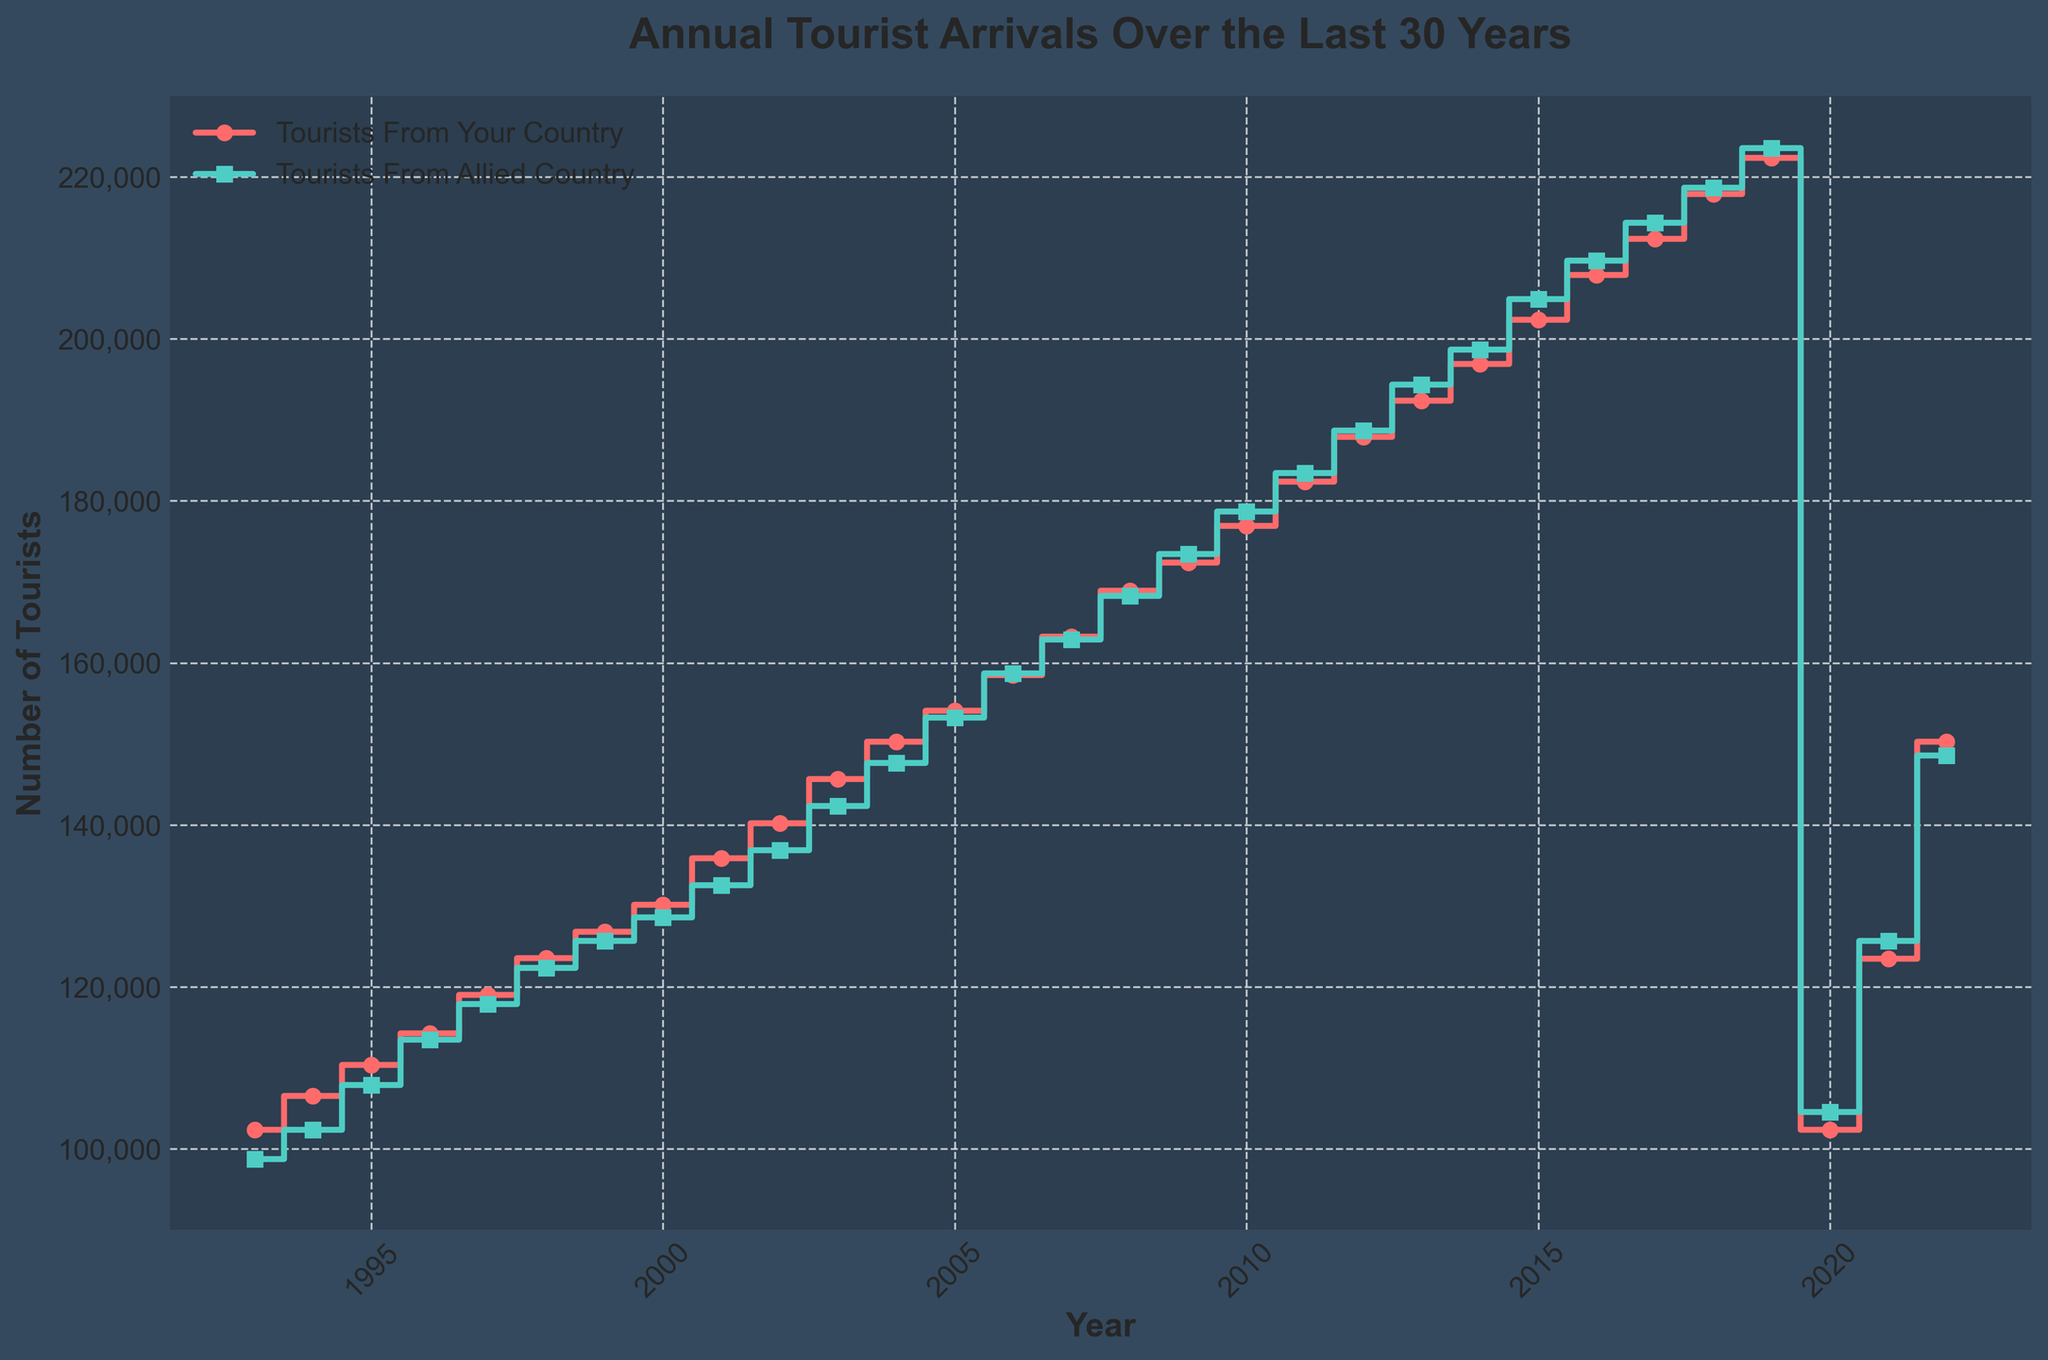What is the title of the figure? The title of the figure is displayed at the top center of the plot in a larger font size compared to other texts. It reads "Annual Tourist Arrivals Over the Last 30 Years".
Answer: Annual Tourist Arrivals Over the Last 30 Years What do the colors in the stair plot represent? The stair plot uses two different colors to distinguish between the data series. The red line represents "Tourists From Your Country" and the teal line represents "Tourists From Allied Country".
Answer: Tourists From Your Country (red) and Tourists From Allied Country (teal) How many years are displayed in the plot? The x-axis of the plot displays the years from 1993 to 2022. By counting the tick marks or data points, it can be determined that there are 30 years displayed.
Answer: 30 How did tourist arrivals from your country compare to those from the allied country in 2008? By examining the y-values of the lines in 2008, tourist arrivals from your country are slightly higher than those from the allied country. Specifically, 168,902 tourists came from your country, compared to 168,234 from the allied country.
Answer: 168,902 vs 168,234 What was the effect of the 2020 event on tourist arrivals? The plot shows a significant drop in tourist arrivals for both countries in 2020, indicated by a large downward step. Specifically, tourists from your country dropped to 102,345, and those from the allied country dropped to 104,567.
Answer: Significant drop What is the overall trend in the number of tourists from both countries over the 30 years? Both data series show an overall increasing trend from 1993 until the sharp drop in 2020, followed by a recovery trend in 2021 and 2022. This can be seen by the upward movement of the lines over time.
Answer: Increasing trend until 2020, then recovery What was the difference in the number of tourists between the two countries in 1995? In 1995, the number of tourists from your country was 110,394, and from the allied country was 107,890. Subtracting the two numbers to find the difference: 110,394 - 107,890 = 2,504.
Answer: 2,504 What is the highest number of tourists from the allied neighboring country over the 30 years? The highest point on the teal line represents the maximum number of tourists. This occurs in 2019 with 223,567 tourists from the allied country.
Answer: 223,567 Which year had the closest number of tourist arrivals from the two countries? By comparing the lines, 2020 had the closest numbers with tourists from your country at 102,345 and the allied country at 104,567, resulting in a difference of 2,222.
Answer: 2020 How do the 2022 tourist arrival numbers compare to the early 1990s? In 2022, the tourist numbers for your country are similar to the early 2000s, and for the allied country, they compare to around 2005 levels. Specifically, 150,234 for your country and 148,567 for the allied country in 2022.
Answer: Similar to early 2000s for your country and 2005 for the allied country 